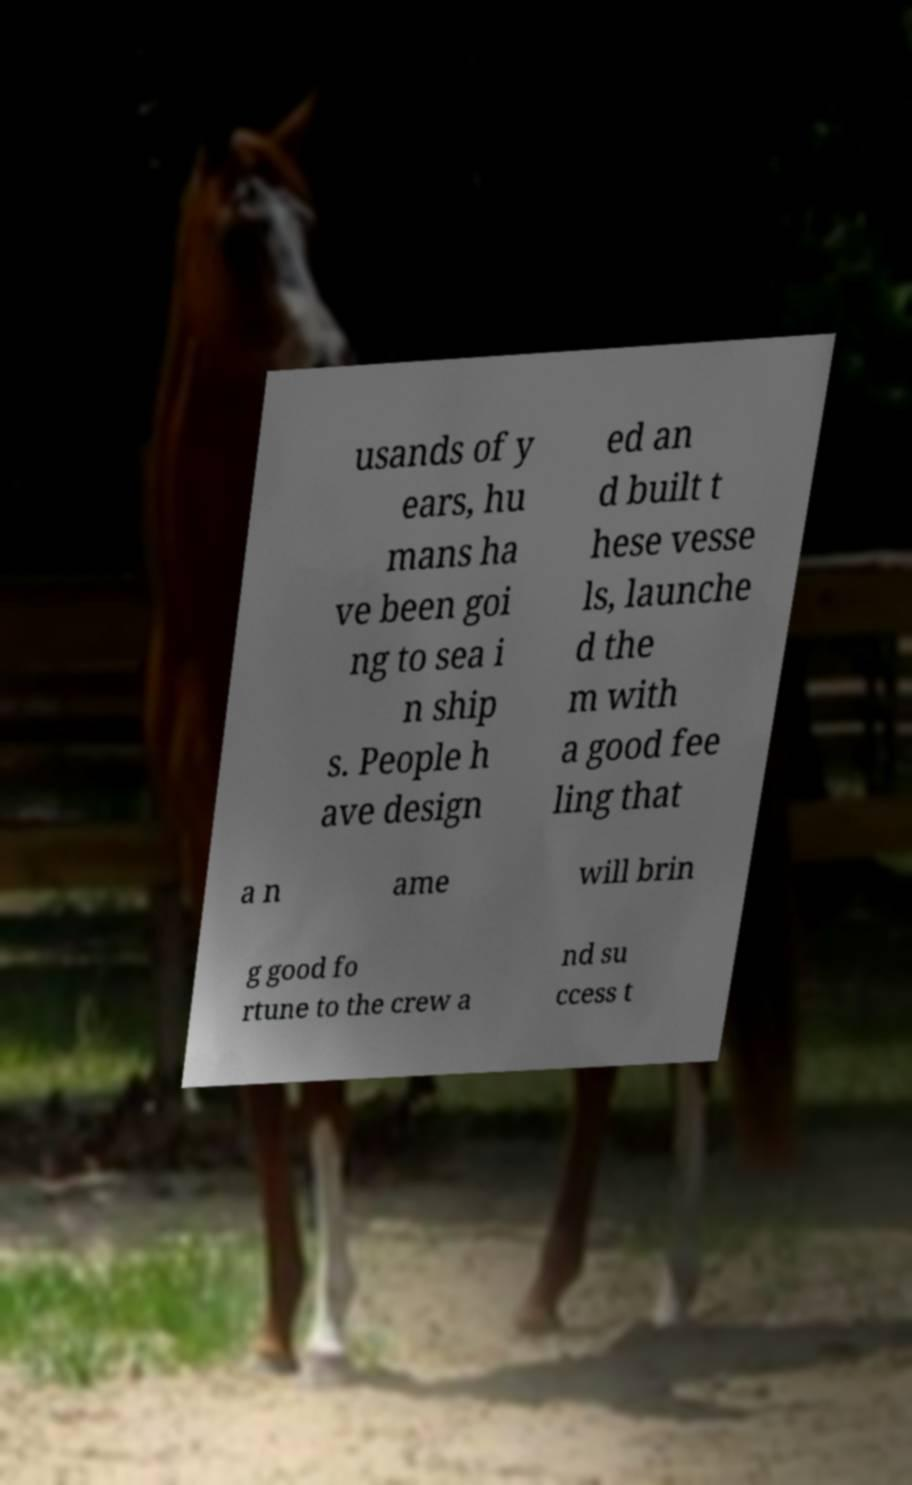Can you read and provide the text displayed in the image?This photo seems to have some interesting text. Can you extract and type it out for me? usands of y ears, hu mans ha ve been goi ng to sea i n ship s. People h ave design ed an d built t hese vesse ls, launche d the m with a good fee ling that a n ame will brin g good fo rtune to the crew a nd su ccess t 